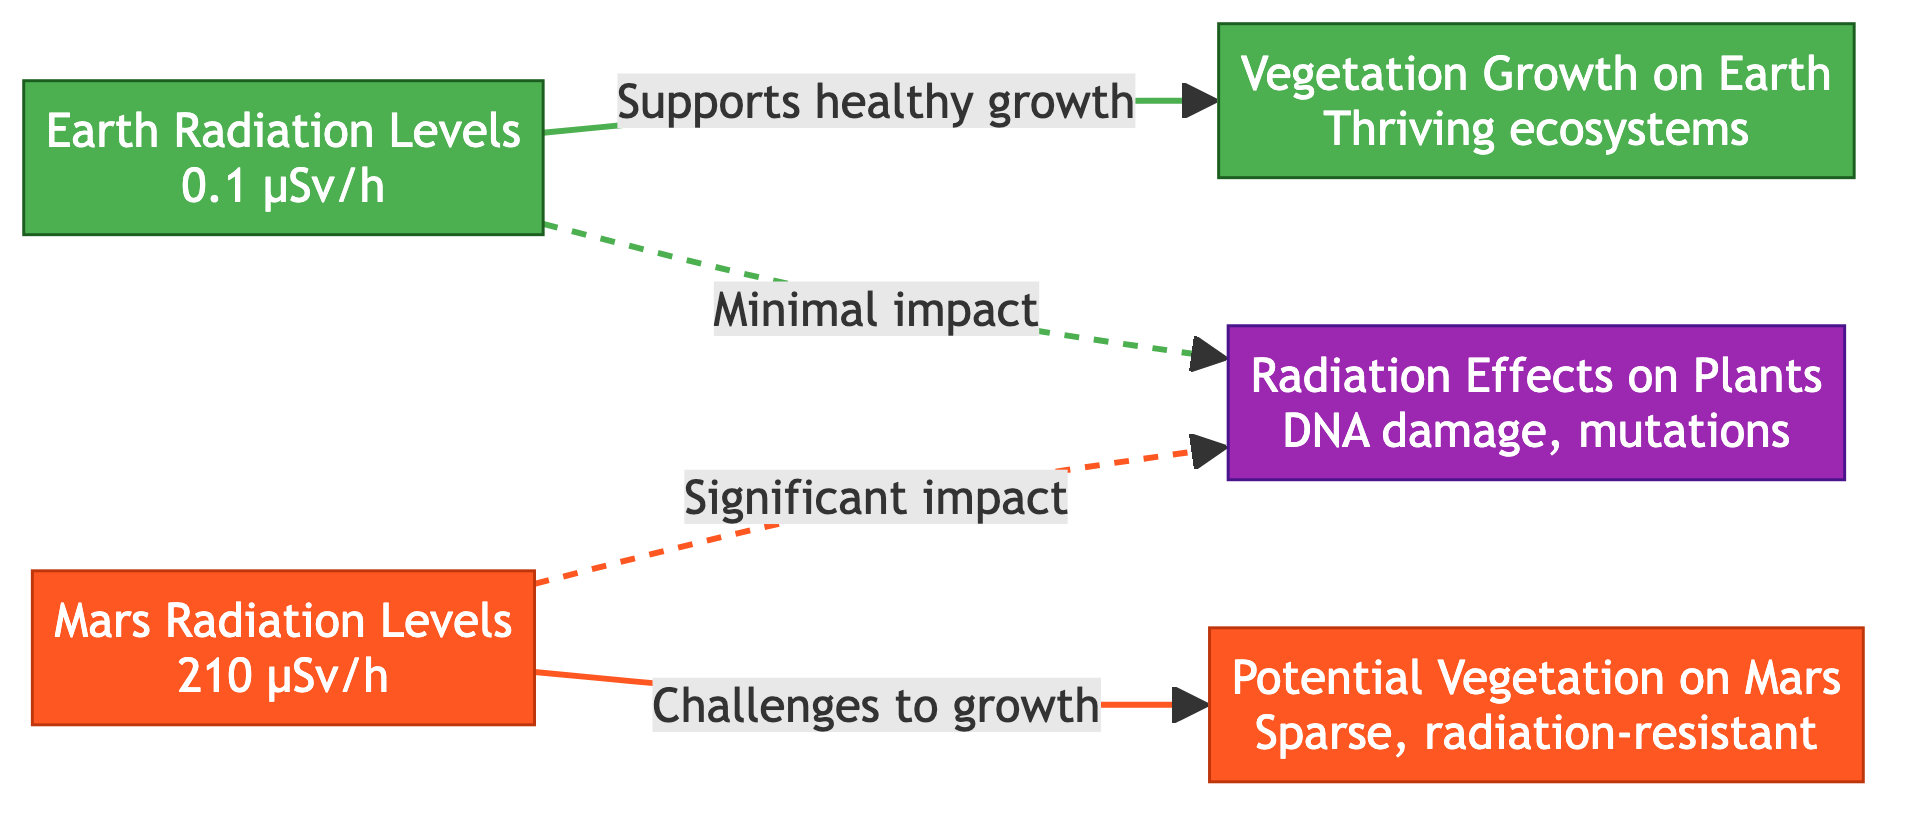What are the radiation levels on Earth? The diagram indicates that the radiation levels on Earth are 0.1 µSv/h, as shown in the Earth radiation levels node.
Answer: 0.1 µSv/h What are the radiation levels on Mars? The Mars radiation levels node displays that the radiation levels on Mars are 210 µSv/h.
Answer: 210 µSv/h How does Earth radiation impact vegetation growth? The diagram shows a direct connection from Earth radiation levels to vegetation growth on Earth, indicating that it supports healthy growth.
Answer: Supports healthy growth What is the potential vegetation situation on Mars? The Mars vegetation node describes potential vegetation on Mars as sparse and radiation-resistant, thus answering the query directly.
Answer: Sparse, radiation-resistant What is the significance of radiation effects on Earth? The diagram indicates that the impact of radiation on plants on Earth is minimal, forming a dashed line from Earth radiation levels to radiation effects.
Answer: Minimal impact What is the impact of Mars radiation on plant growth? The diagram depicts a significant impact of radiation on plants on Mars, as seen in the connection from Mars radiation levels to radiation effects indicated by a solid line.
Answer: Significant impact How many nodes represent vegetation conditions in the diagram? There are two nodes concerned with vegetation conditions: one for Earth and one for Mars, leading to a clear count.
Answer: 2 What color represents Earth in the diagram? The Earth nodes are filled with a green color, as specified in the color settings of the diagram.
Answer: Green What indicates the difference in vegetation growth between Earth and Mars? The diagram shows a clear differentiation with arrows describing the conditions on Earth (thriving ecosystems) versus Mars (sparse, radiation-resistant), leading to distinct descriptions.
Answer: Thriving ecosystems vs. Sparse, radiation-resistant What type of line shows the connection from Earth radiation to its effects? The connection depicted from Earth radiation to its effects is represented by a dashed line, indicating minimal impact.
Answer: Dashed line 